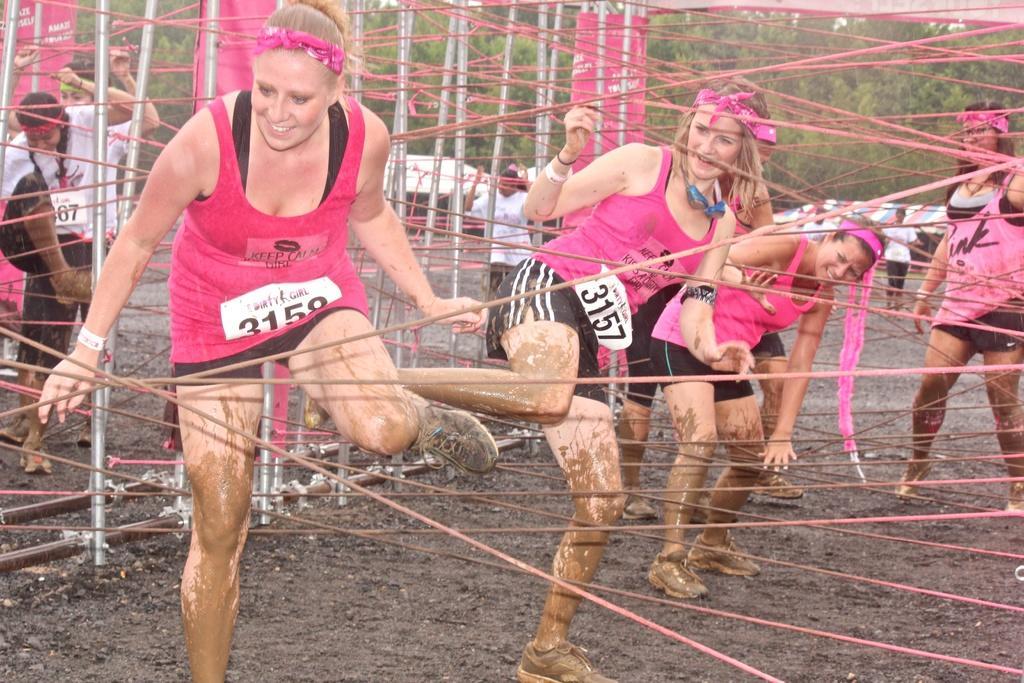Can you describe this image briefly? In this picture there are girls in the center of the image, they are playing. 